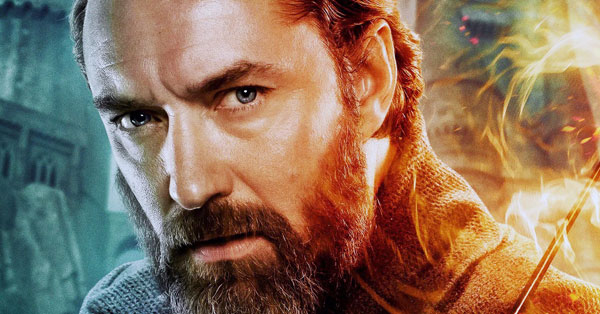What is the character thinking about in this moment? The character appears deeply contemplative, perhaps reflecting on a significant decision or strategy. The intensity in his eyes suggests he is weighing the consequences, considering the impact on those around him. The magical sparks flying around may symbolize the weight of his thoughts, as if he is channeling his inner power to find the best course of action. Can you describe what might be happening off-screen? Off-screen, there could be a dynamic scene unfolding. Given the mystical elements like the orange sparks and the presence of a castle in the background, it's possible that this character is amidst a grand confrontation or battle. Other characters might be preparing for a crucial moment, with spells being cast and powerful forces clashing. The tension in the air could be palpable, making this character's focus even more critical. 